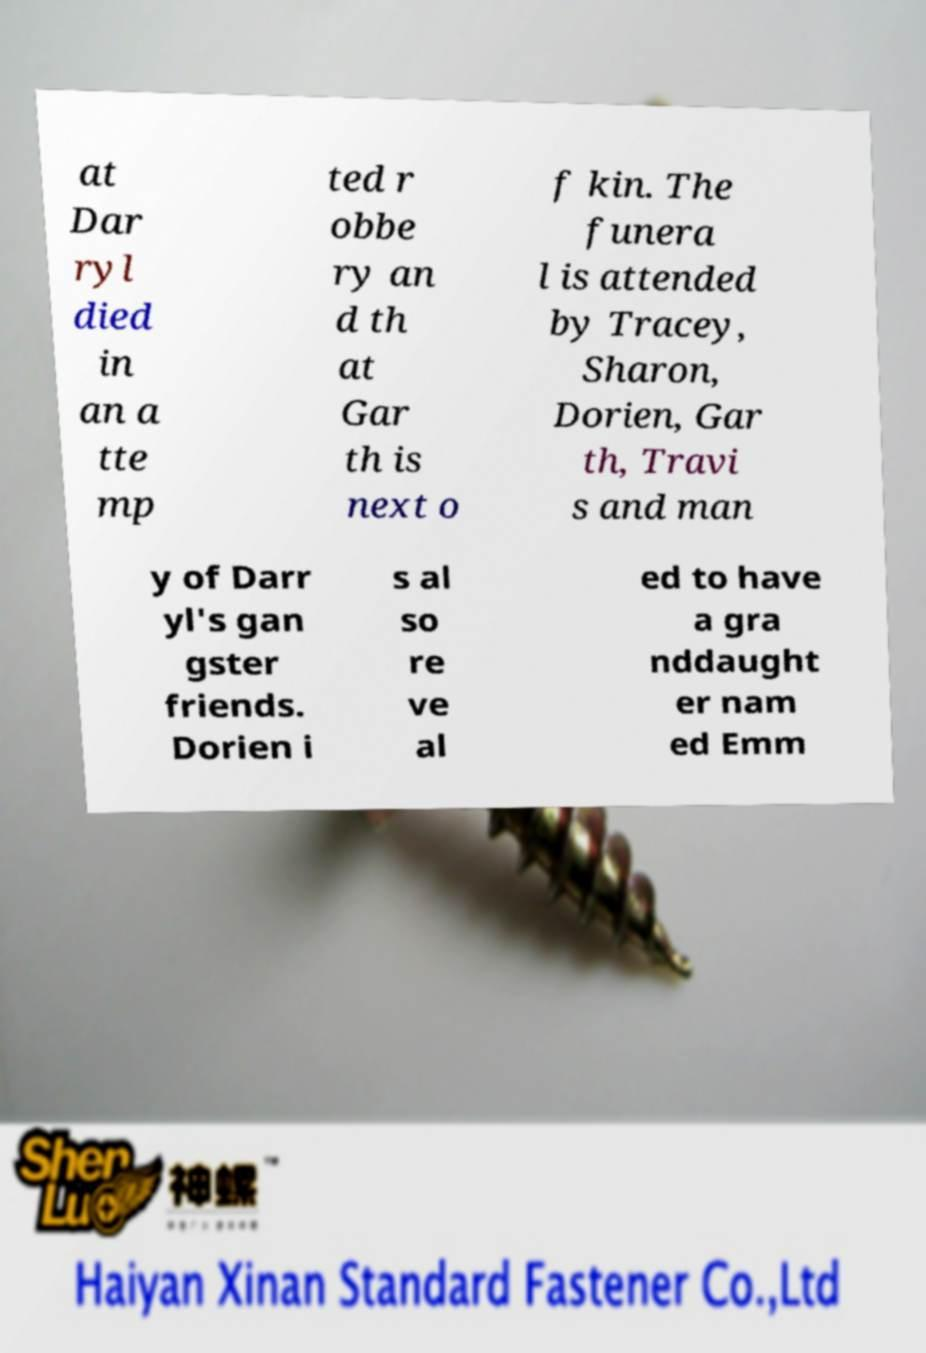Can you accurately transcribe the text from the provided image for me? at Dar ryl died in an a tte mp ted r obbe ry an d th at Gar th is next o f kin. The funera l is attended by Tracey, Sharon, Dorien, Gar th, Travi s and man y of Darr yl's gan gster friends. Dorien i s al so re ve al ed to have a gra nddaught er nam ed Emm 